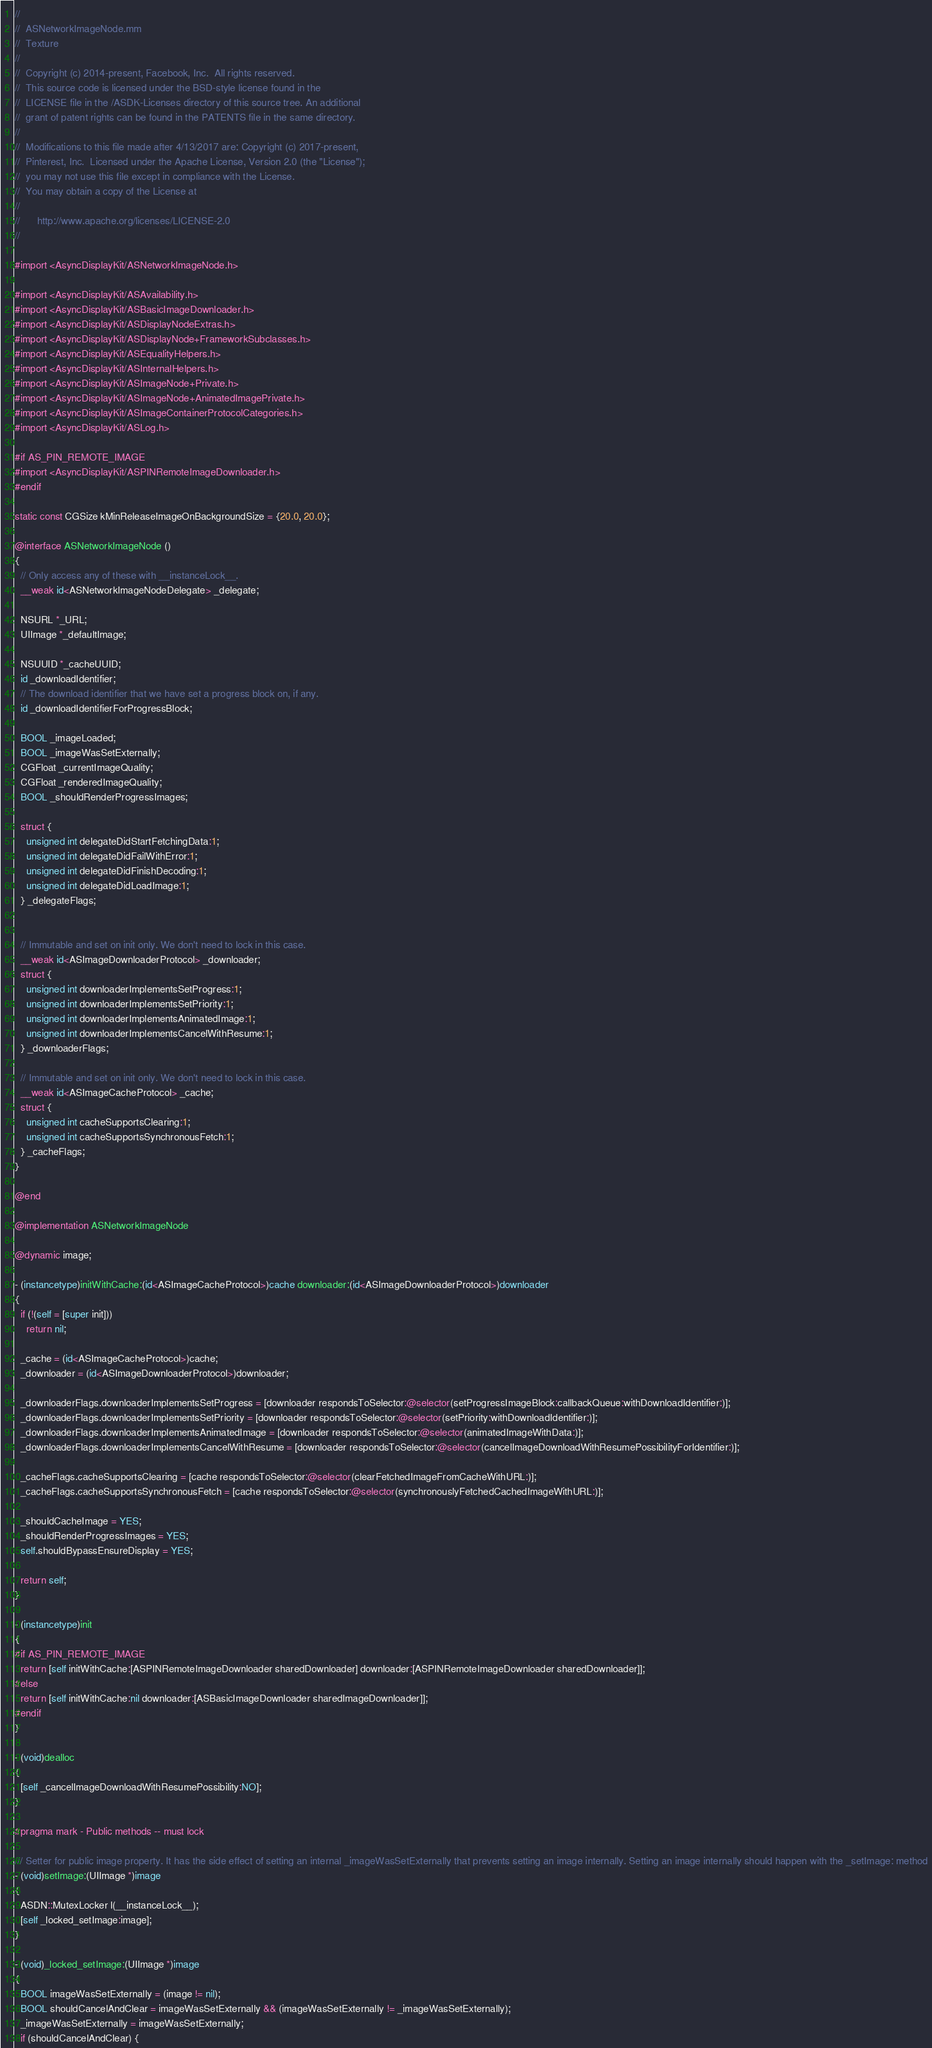<code> <loc_0><loc_0><loc_500><loc_500><_ObjectiveC_>//
//  ASNetworkImageNode.mm
//  Texture
//
//  Copyright (c) 2014-present, Facebook, Inc.  All rights reserved.
//  This source code is licensed under the BSD-style license found in the
//  LICENSE file in the /ASDK-Licenses directory of this source tree. An additional
//  grant of patent rights can be found in the PATENTS file in the same directory.
//
//  Modifications to this file made after 4/13/2017 are: Copyright (c) 2017-present,
//  Pinterest, Inc.  Licensed under the Apache License, Version 2.0 (the "License");
//  you may not use this file except in compliance with the License.
//  You may obtain a copy of the License at
//
//      http://www.apache.org/licenses/LICENSE-2.0
//

#import <AsyncDisplayKit/ASNetworkImageNode.h>

#import <AsyncDisplayKit/ASAvailability.h>
#import <AsyncDisplayKit/ASBasicImageDownloader.h>
#import <AsyncDisplayKit/ASDisplayNodeExtras.h>
#import <AsyncDisplayKit/ASDisplayNode+FrameworkSubclasses.h>
#import <AsyncDisplayKit/ASEqualityHelpers.h>
#import <AsyncDisplayKit/ASInternalHelpers.h>
#import <AsyncDisplayKit/ASImageNode+Private.h>
#import <AsyncDisplayKit/ASImageNode+AnimatedImagePrivate.h>
#import <AsyncDisplayKit/ASImageContainerProtocolCategories.h>
#import <AsyncDisplayKit/ASLog.h>

#if AS_PIN_REMOTE_IMAGE
#import <AsyncDisplayKit/ASPINRemoteImageDownloader.h>
#endif

static const CGSize kMinReleaseImageOnBackgroundSize = {20.0, 20.0};

@interface ASNetworkImageNode ()
{
  // Only access any of these with __instanceLock__.
  __weak id<ASNetworkImageNodeDelegate> _delegate;

  NSURL *_URL;
  UIImage *_defaultImage;

  NSUUID *_cacheUUID;
  id _downloadIdentifier;
  // The download identifier that we have set a progress block on, if any.
  id _downloadIdentifierForProgressBlock;

  BOOL _imageLoaded;
  BOOL _imageWasSetExternally;
  CGFloat _currentImageQuality;
  CGFloat _renderedImageQuality;
  BOOL _shouldRenderProgressImages;

  struct {
    unsigned int delegateDidStartFetchingData:1;
    unsigned int delegateDidFailWithError:1;
    unsigned int delegateDidFinishDecoding:1;
    unsigned int delegateDidLoadImage:1;
  } _delegateFlags;

  
  // Immutable and set on init only. We don't need to lock in this case.
  __weak id<ASImageDownloaderProtocol> _downloader;
  struct {
    unsigned int downloaderImplementsSetProgress:1;
    unsigned int downloaderImplementsSetPriority:1;
    unsigned int downloaderImplementsAnimatedImage:1;
    unsigned int downloaderImplementsCancelWithResume:1;
  } _downloaderFlags;

  // Immutable and set on init only. We don't need to lock in this case.
  __weak id<ASImageCacheProtocol> _cache;
  struct {
    unsigned int cacheSupportsClearing:1;
    unsigned int cacheSupportsSynchronousFetch:1;
  } _cacheFlags;
}

@end

@implementation ASNetworkImageNode

@dynamic image;

- (instancetype)initWithCache:(id<ASImageCacheProtocol>)cache downloader:(id<ASImageDownloaderProtocol>)downloader
{
  if (!(self = [super init]))
    return nil;

  _cache = (id<ASImageCacheProtocol>)cache;
  _downloader = (id<ASImageDownloaderProtocol>)downloader;
  
  _downloaderFlags.downloaderImplementsSetProgress = [downloader respondsToSelector:@selector(setProgressImageBlock:callbackQueue:withDownloadIdentifier:)];
  _downloaderFlags.downloaderImplementsSetPriority = [downloader respondsToSelector:@selector(setPriority:withDownloadIdentifier:)];
  _downloaderFlags.downloaderImplementsAnimatedImage = [downloader respondsToSelector:@selector(animatedImageWithData:)];
  _downloaderFlags.downloaderImplementsCancelWithResume = [downloader respondsToSelector:@selector(cancelImageDownloadWithResumePossibilityForIdentifier:)];

  _cacheFlags.cacheSupportsClearing = [cache respondsToSelector:@selector(clearFetchedImageFromCacheWithURL:)];
  _cacheFlags.cacheSupportsSynchronousFetch = [cache respondsToSelector:@selector(synchronouslyFetchedCachedImageWithURL:)];
  
  _shouldCacheImage = YES;
  _shouldRenderProgressImages = YES;
  self.shouldBypassEnsureDisplay = YES;

  return self;
}

- (instancetype)init
{
#if AS_PIN_REMOTE_IMAGE
  return [self initWithCache:[ASPINRemoteImageDownloader sharedDownloader] downloader:[ASPINRemoteImageDownloader sharedDownloader]];
#else
  return [self initWithCache:nil downloader:[ASBasicImageDownloader sharedImageDownloader]];
#endif
}

- (void)dealloc
{
  [self _cancelImageDownloadWithResumePossibility:NO];
}

#pragma mark - Public methods -- must lock

/// Setter for public image property. It has the side effect of setting an internal _imageWasSetExternally that prevents setting an image internally. Setting an image internally should happen with the _setImage: method
- (void)setImage:(UIImage *)image
{
  ASDN::MutexLocker l(__instanceLock__);
  [self _locked_setImage:image];
}

- (void)_locked_setImage:(UIImage *)image
{
  BOOL imageWasSetExternally = (image != nil);
  BOOL shouldCancelAndClear = imageWasSetExternally && (imageWasSetExternally != _imageWasSetExternally);
  _imageWasSetExternally = imageWasSetExternally;
  if (shouldCancelAndClear) {</code> 